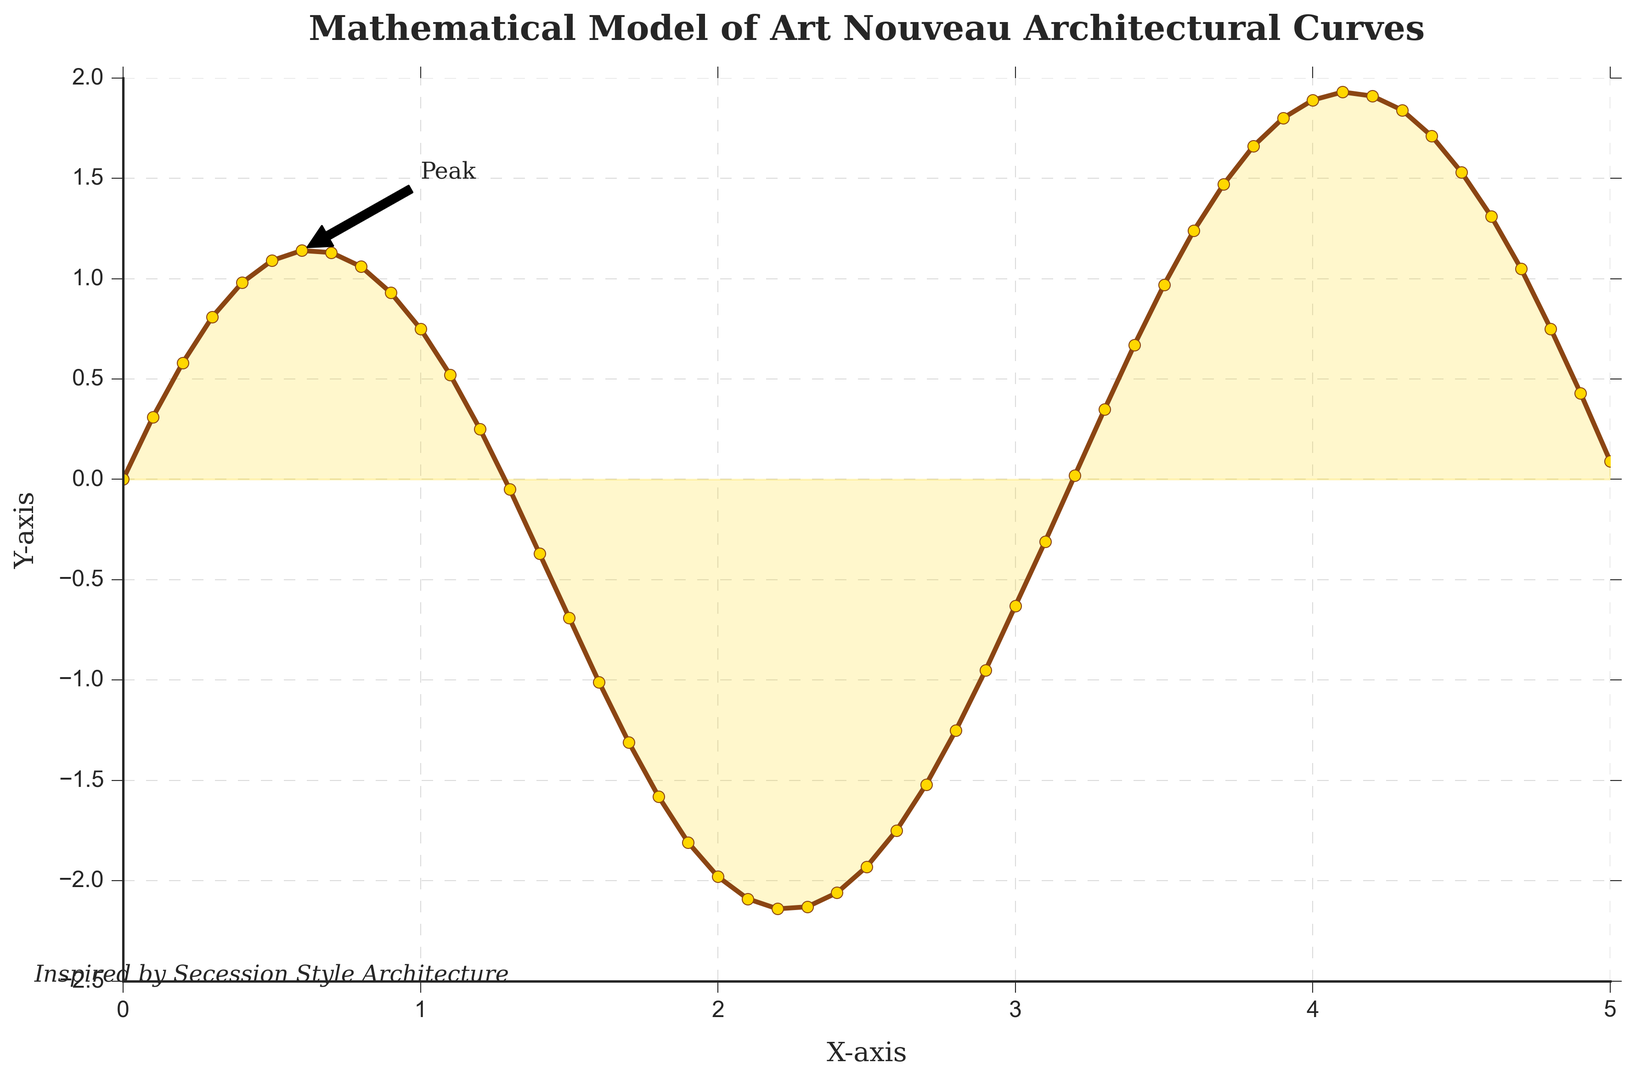What is the peak value in the plot? The highest point of the curve is annotated with the text "Peak." Looking at the plot, this peak occurs at approximately the y-value of 1.14.
Answer: 1.14 At what x-value does the curve reach its lowest point? To identify the lowest point on the curve, observe the point where the y-value is the smallest. The plot shows that the lowest y-value is -2.14, which occurs at approximately x = 2.2.
Answer: 2.2 How does the y-value change between x = 0 and x = 1? At x = 0, the y-value is 0. The curve gradually rises until reaching its peak around x = 0.6 and y = 1.14. Then, it begins to descend, reaching about y = 0.75 at x = 1.
Answer: It increases and then decreases What is the difference in y-value between x = 0.6 and x = 2.2? At x = 0.6, the y-value is 1.14, and at x = 2.2, the y-value is -2.14. The difference can be calculated as 1.14 - (-2.14) = 1.14 + 2.14 = 3.28.
Answer: 3.28 Compare the y-values at x = 0.5 and x = 4.5. Which one is greater? The y-value at x = 0.5 is 1.09, and at x = 4.5, it is 1.53. Clearly, 1.53 (y-value at x = 4.5) is greater than 1.09 (y-value at x = 0.5).
Answer: x = 4.5 What is the y-value at x = 4 compared to x = 5? The y-value at x = 4 is 1.89, and at x = 5, it is 0.09. So, 1.89 (at x = 4) is significantly higher than 0.09 (at x = 5).
Answer: x = 4 Describe the general shape of the curve from x = 0 to x = 5. The curve starts at y = 0 and follows an upward trend, reaching a peak at around x = 0.6. Then it decreases steadily, hitting a low at about x = 2.2. After that, the curve rises again but with less steepness, leveling out by x = 4.5 and then drops slightly towards x = 5.
Answer: Up, then down, slightly up again How many times does the curve cross the x-axis? The curve crosses the x-axis where the y-value is 0. Observing the plot, the curve crosses the x-axis three times: at x = 0, around x = 3.2, and slightly after x = 5.
Answer: 3 What is the annotated arrow indicating in the plot? The plot includes an annotation labeled "Peak" with an arrow pointing to the highest point on the curve, which is at approximately x = 0.6 and y = 1.14.
Answer: Peak position Find the average of the y-values at x = 1, x = 2, and x = 3. The y-values at x = 1, 2, and 3 are 0.75, -1.98, and -0.63, respectively. The average is calculated as (0.75 - 1.98 - 0.63)/3 = -1.86/3 = -0.62.
Answer: -0.62 